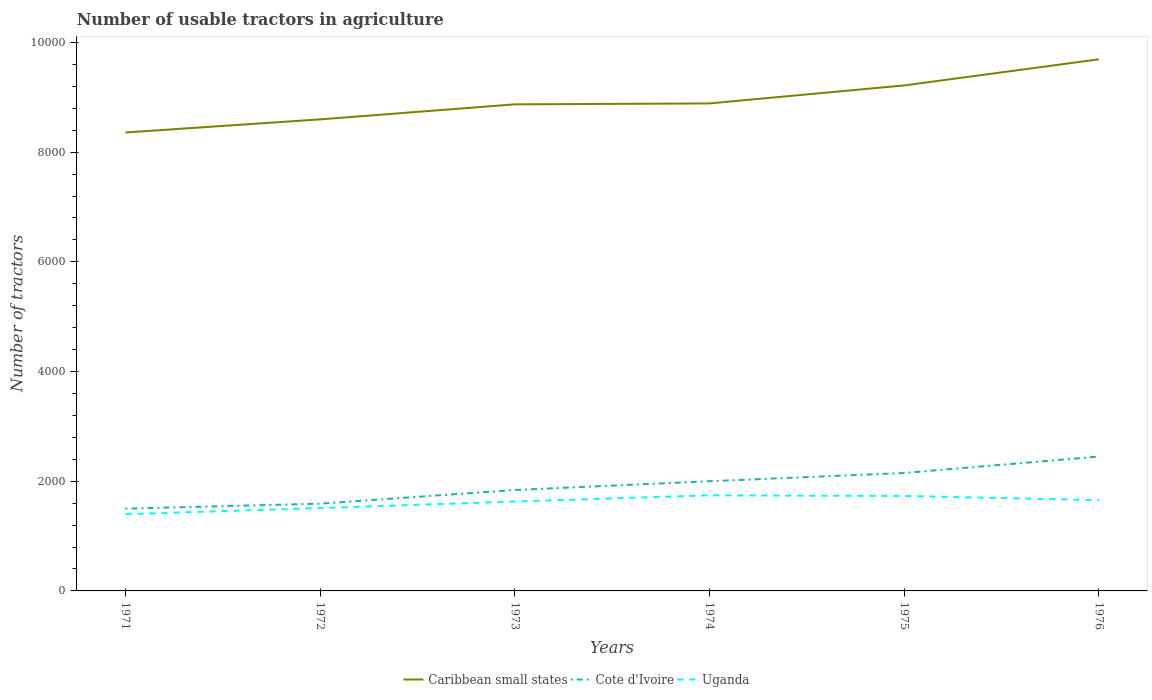How many different coloured lines are there?
Your answer should be very brief. 3. Does the line corresponding to Uganda intersect with the line corresponding to Caribbean small states?
Ensure brevity in your answer.  No. Is the number of lines equal to the number of legend labels?
Your answer should be very brief. Yes. Across all years, what is the maximum number of usable tractors in agriculture in Cote d'Ivoire?
Make the answer very short. 1500. In which year was the number of usable tractors in agriculture in Cote d'Ivoire maximum?
Offer a very short reply. 1971. What is the total number of usable tractors in agriculture in Cote d'Ivoire in the graph?
Your response must be concise. -409. What is the difference between the highest and the second highest number of usable tractors in agriculture in Uganda?
Make the answer very short. 343. What is the difference between the highest and the lowest number of usable tractors in agriculture in Cote d'Ivoire?
Provide a succinct answer. 3. Is the number of usable tractors in agriculture in Uganda strictly greater than the number of usable tractors in agriculture in Caribbean small states over the years?
Provide a short and direct response. Yes. How many lines are there?
Your response must be concise. 3. How many years are there in the graph?
Provide a succinct answer. 6. Does the graph contain grids?
Provide a succinct answer. No. What is the title of the graph?
Provide a succinct answer. Number of usable tractors in agriculture. What is the label or title of the X-axis?
Give a very brief answer. Years. What is the label or title of the Y-axis?
Provide a short and direct response. Number of tractors. What is the Number of tractors of Caribbean small states in 1971?
Your answer should be very brief. 8358. What is the Number of tractors of Cote d'Ivoire in 1971?
Your answer should be compact. 1500. What is the Number of tractors of Uganda in 1971?
Provide a short and direct response. 1400. What is the Number of tractors in Caribbean small states in 1972?
Ensure brevity in your answer.  8597. What is the Number of tractors of Cote d'Ivoire in 1972?
Your answer should be very brief. 1591. What is the Number of tractors of Uganda in 1972?
Ensure brevity in your answer.  1510. What is the Number of tractors of Caribbean small states in 1973?
Your response must be concise. 8871. What is the Number of tractors of Cote d'Ivoire in 1973?
Offer a terse response. 1840. What is the Number of tractors in Uganda in 1973?
Offer a very short reply. 1630. What is the Number of tractors of Caribbean small states in 1974?
Provide a short and direct response. 8888. What is the Number of tractors of Cote d'Ivoire in 1974?
Your answer should be very brief. 2000. What is the Number of tractors of Uganda in 1974?
Keep it short and to the point. 1743. What is the Number of tractors in Caribbean small states in 1975?
Keep it short and to the point. 9216. What is the Number of tractors of Cote d'Ivoire in 1975?
Give a very brief answer. 2150. What is the Number of tractors in Uganda in 1975?
Your answer should be very brief. 1731. What is the Number of tractors of Caribbean small states in 1976?
Offer a terse response. 9692. What is the Number of tractors in Cote d'Ivoire in 1976?
Ensure brevity in your answer.  2450. What is the Number of tractors in Uganda in 1976?
Your response must be concise. 1656. Across all years, what is the maximum Number of tractors in Caribbean small states?
Keep it short and to the point. 9692. Across all years, what is the maximum Number of tractors of Cote d'Ivoire?
Offer a terse response. 2450. Across all years, what is the maximum Number of tractors in Uganda?
Make the answer very short. 1743. Across all years, what is the minimum Number of tractors in Caribbean small states?
Your answer should be very brief. 8358. Across all years, what is the minimum Number of tractors of Cote d'Ivoire?
Keep it short and to the point. 1500. Across all years, what is the minimum Number of tractors of Uganda?
Offer a very short reply. 1400. What is the total Number of tractors in Caribbean small states in the graph?
Offer a very short reply. 5.36e+04. What is the total Number of tractors in Cote d'Ivoire in the graph?
Provide a succinct answer. 1.15e+04. What is the total Number of tractors in Uganda in the graph?
Offer a terse response. 9670. What is the difference between the Number of tractors of Caribbean small states in 1971 and that in 1972?
Keep it short and to the point. -239. What is the difference between the Number of tractors in Cote d'Ivoire in 1971 and that in 1972?
Keep it short and to the point. -91. What is the difference between the Number of tractors of Uganda in 1971 and that in 1972?
Keep it short and to the point. -110. What is the difference between the Number of tractors of Caribbean small states in 1971 and that in 1973?
Provide a succinct answer. -513. What is the difference between the Number of tractors of Cote d'Ivoire in 1971 and that in 1973?
Give a very brief answer. -340. What is the difference between the Number of tractors of Uganda in 1971 and that in 1973?
Your answer should be compact. -230. What is the difference between the Number of tractors of Caribbean small states in 1971 and that in 1974?
Offer a terse response. -530. What is the difference between the Number of tractors of Cote d'Ivoire in 1971 and that in 1974?
Your answer should be very brief. -500. What is the difference between the Number of tractors in Uganda in 1971 and that in 1974?
Keep it short and to the point. -343. What is the difference between the Number of tractors in Caribbean small states in 1971 and that in 1975?
Keep it short and to the point. -858. What is the difference between the Number of tractors in Cote d'Ivoire in 1971 and that in 1975?
Make the answer very short. -650. What is the difference between the Number of tractors in Uganda in 1971 and that in 1975?
Your response must be concise. -331. What is the difference between the Number of tractors in Caribbean small states in 1971 and that in 1976?
Keep it short and to the point. -1334. What is the difference between the Number of tractors in Cote d'Ivoire in 1971 and that in 1976?
Offer a terse response. -950. What is the difference between the Number of tractors of Uganda in 1971 and that in 1976?
Offer a terse response. -256. What is the difference between the Number of tractors in Caribbean small states in 1972 and that in 1973?
Give a very brief answer. -274. What is the difference between the Number of tractors in Cote d'Ivoire in 1972 and that in 1973?
Give a very brief answer. -249. What is the difference between the Number of tractors in Uganda in 1972 and that in 1973?
Your answer should be very brief. -120. What is the difference between the Number of tractors in Caribbean small states in 1972 and that in 1974?
Your answer should be very brief. -291. What is the difference between the Number of tractors in Cote d'Ivoire in 1972 and that in 1974?
Give a very brief answer. -409. What is the difference between the Number of tractors of Uganda in 1972 and that in 1974?
Your answer should be compact. -233. What is the difference between the Number of tractors in Caribbean small states in 1972 and that in 1975?
Make the answer very short. -619. What is the difference between the Number of tractors in Cote d'Ivoire in 1972 and that in 1975?
Ensure brevity in your answer.  -559. What is the difference between the Number of tractors in Uganda in 1972 and that in 1975?
Your answer should be very brief. -221. What is the difference between the Number of tractors of Caribbean small states in 1972 and that in 1976?
Provide a succinct answer. -1095. What is the difference between the Number of tractors in Cote d'Ivoire in 1972 and that in 1976?
Your answer should be very brief. -859. What is the difference between the Number of tractors of Uganda in 1972 and that in 1976?
Offer a terse response. -146. What is the difference between the Number of tractors in Cote d'Ivoire in 1973 and that in 1974?
Ensure brevity in your answer.  -160. What is the difference between the Number of tractors in Uganda in 1973 and that in 1974?
Your answer should be very brief. -113. What is the difference between the Number of tractors in Caribbean small states in 1973 and that in 1975?
Offer a very short reply. -345. What is the difference between the Number of tractors in Cote d'Ivoire in 1973 and that in 1975?
Ensure brevity in your answer.  -310. What is the difference between the Number of tractors in Uganda in 1973 and that in 1975?
Your response must be concise. -101. What is the difference between the Number of tractors in Caribbean small states in 1973 and that in 1976?
Make the answer very short. -821. What is the difference between the Number of tractors of Cote d'Ivoire in 1973 and that in 1976?
Ensure brevity in your answer.  -610. What is the difference between the Number of tractors of Caribbean small states in 1974 and that in 1975?
Offer a terse response. -328. What is the difference between the Number of tractors in Cote d'Ivoire in 1974 and that in 1975?
Provide a short and direct response. -150. What is the difference between the Number of tractors of Caribbean small states in 1974 and that in 1976?
Give a very brief answer. -804. What is the difference between the Number of tractors of Cote d'Ivoire in 1974 and that in 1976?
Ensure brevity in your answer.  -450. What is the difference between the Number of tractors of Uganda in 1974 and that in 1976?
Your response must be concise. 87. What is the difference between the Number of tractors in Caribbean small states in 1975 and that in 1976?
Your answer should be very brief. -476. What is the difference between the Number of tractors in Cote d'Ivoire in 1975 and that in 1976?
Offer a very short reply. -300. What is the difference between the Number of tractors of Uganda in 1975 and that in 1976?
Your answer should be very brief. 75. What is the difference between the Number of tractors in Caribbean small states in 1971 and the Number of tractors in Cote d'Ivoire in 1972?
Provide a succinct answer. 6767. What is the difference between the Number of tractors of Caribbean small states in 1971 and the Number of tractors of Uganda in 1972?
Keep it short and to the point. 6848. What is the difference between the Number of tractors in Cote d'Ivoire in 1971 and the Number of tractors in Uganda in 1972?
Ensure brevity in your answer.  -10. What is the difference between the Number of tractors of Caribbean small states in 1971 and the Number of tractors of Cote d'Ivoire in 1973?
Your response must be concise. 6518. What is the difference between the Number of tractors of Caribbean small states in 1971 and the Number of tractors of Uganda in 1973?
Offer a very short reply. 6728. What is the difference between the Number of tractors of Cote d'Ivoire in 1971 and the Number of tractors of Uganda in 1973?
Give a very brief answer. -130. What is the difference between the Number of tractors of Caribbean small states in 1971 and the Number of tractors of Cote d'Ivoire in 1974?
Offer a very short reply. 6358. What is the difference between the Number of tractors in Caribbean small states in 1971 and the Number of tractors in Uganda in 1974?
Keep it short and to the point. 6615. What is the difference between the Number of tractors of Cote d'Ivoire in 1971 and the Number of tractors of Uganda in 1974?
Give a very brief answer. -243. What is the difference between the Number of tractors of Caribbean small states in 1971 and the Number of tractors of Cote d'Ivoire in 1975?
Your answer should be compact. 6208. What is the difference between the Number of tractors of Caribbean small states in 1971 and the Number of tractors of Uganda in 1975?
Provide a short and direct response. 6627. What is the difference between the Number of tractors in Cote d'Ivoire in 1971 and the Number of tractors in Uganda in 1975?
Provide a succinct answer. -231. What is the difference between the Number of tractors in Caribbean small states in 1971 and the Number of tractors in Cote d'Ivoire in 1976?
Your answer should be compact. 5908. What is the difference between the Number of tractors in Caribbean small states in 1971 and the Number of tractors in Uganda in 1976?
Provide a succinct answer. 6702. What is the difference between the Number of tractors in Cote d'Ivoire in 1971 and the Number of tractors in Uganda in 1976?
Keep it short and to the point. -156. What is the difference between the Number of tractors in Caribbean small states in 1972 and the Number of tractors in Cote d'Ivoire in 1973?
Ensure brevity in your answer.  6757. What is the difference between the Number of tractors of Caribbean small states in 1972 and the Number of tractors of Uganda in 1973?
Provide a short and direct response. 6967. What is the difference between the Number of tractors of Cote d'Ivoire in 1972 and the Number of tractors of Uganda in 1973?
Your answer should be compact. -39. What is the difference between the Number of tractors in Caribbean small states in 1972 and the Number of tractors in Cote d'Ivoire in 1974?
Make the answer very short. 6597. What is the difference between the Number of tractors of Caribbean small states in 1972 and the Number of tractors of Uganda in 1974?
Keep it short and to the point. 6854. What is the difference between the Number of tractors of Cote d'Ivoire in 1972 and the Number of tractors of Uganda in 1974?
Your answer should be compact. -152. What is the difference between the Number of tractors of Caribbean small states in 1972 and the Number of tractors of Cote d'Ivoire in 1975?
Provide a short and direct response. 6447. What is the difference between the Number of tractors of Caribbean small states in 1972 and the Number of tractors of Uganda in 1975?
Offer a very short reply. 6866. What is the difference between the Number of tractors in Cote d'Ivoire in 1972 and the Number of tractors in Uganda in 1975?
Make the answer very short. -140. What is the difference between the Number of tractors in Caribbean small states in 1972 and the Number of tractors in Cote d'Ivoire in 1976?
Your answer should be compact. 6147. What is the difference between the Number of tractors in Caribbean small states in 1972 and the Number of tractors in Uganda in 1976?
Your response must be concise. 6941. What is the difference between the Number of tractors of Cote d'Ivoire in 1972 and the Number of tractors of Uganda in 1976?
Make the answer very short. -65. What is the difference between the Number of tractors in Caribbean small states in 1973 and the Number of tractors in Cote d'Ivoire in 1974?
Your answer should be very brief. 6871. What is the difference between the Number of tractors in Caribbean small states in 1973 and the Number of tractors in Uganda in 1974?
Provide a succinct answer. 7128. What is the difference between the Number of tractors of Cote d'Ivoire in 1973 and the Number of tractors of Uganda in 1974?
Keep it short and to the point. 97. What is the difference between the Number of tractors of Caribbean small states in 1973 and the Number of tractors of Cote d'Ivoire in 1975?
Make the answer very short. 6721. What is the difference between the Number of tractors of Caribbean small states in 1973 and the Number of tractors of Uganda in 1975?
Offer a very short reply. 7140. What is the difference between the Number of tractors of Cote d'Ivoire in 1973 and the Number of tractors of Uganda in 1975?
Make the answer very short. 109. What is the difference between the Number of tractors in Caribbean small states in 1973 and the Number of tractors in Cote d'Ivoire in 1976?
Give a very brief answer. 6421. What is the difference between the Number of tractors of Caribbean small states in 1973 and the Number of tractors of Uganda in 1976?
Provide a succinct answer. 7215. What is the difference between the Number of tractors in Cote d'Ivoire in 1973 and the Number of tractors in Uganda in 1976?
Offer a terse response. 184. What is the difference between the Number of tractors of Caribbean small states in 1974 and the Number of tractors of Cote d'Ivoire in 1975?
Ensure brevity in your answer.  6738. What is the difference between the Number of tractors in Caribbean small states in 1974 and the Number of tractors in Uganda in 1975?
Your answer should be compact. 7157. What is the difference between the Number of tractors of Cote d'Ivoire in 1974 and the Number of tractors of Uganda in 1975?
Your response must be concise. 269. What is the difference between the Number of tractors in Caribbean small states in 1974 and the Number of tractors in Cote d'Ivoire in 1976?
Provide a short and direct response. 6438. What is the difference between the Number of tractors in Caribbean small states in 1974 and the Number of tractors in Uganda in 1976?
Offer a very short reply. 7232. What is the difference between the Number of tractors in Cote d'Ivoire in 1974 and the Number of tractors in Uganda in 1976?
Give a very brief answer. 344. What is the difference between the Number of tractors of Caribbean small states in 1975 and the Number of tractors of Cote d'Ivoire in 1976?
Give a very brief answer. 6766. What is the difference between the Number of tractors of Caribbean small states in 1975 and the Number of tractors of Uganda in 1976?
Offer a terse response. 7560. What is the difference between the Number of tractors in Cote d'Ivoire in 1975 and the Number of tractors in Uganda in 1976?
Make the answer very short. 494. What is the average Number of tractors of Caribbean small states per year?
Offer a terse response. 8937. What is the average Number of tractors of Cote d'Ivoire per year?
Offer a very short reply. 1921.83. What is the average Number of tractors in Uganda per year?
Provide a short and direct response. 1611.67. In the year 1971, what is the difference between the Number of tractors of Caribbean small states and Number of tractors of Cote d'Ivoire?
Provide a short and direct response. 6858. In the year 1971, what is the difference between the Number of tractors in Caribbean small states and Number of tractors in Uganda?
Provide a short and direct response. 6958. In the year 1972, what is the difference between the Number of tractors in Caribbean small states and Number of tractors in Cote d'Ivoire?
Offer a terse response. 7006. In the year 1972, what is the difference between the Number of tractors in Caribbean small states and Number of tractors in Uganda?
Offer a very short reply. 7087. In the year 1972, what is the difference between the Number of tractors in Cote d'Ivoire and Number of tractors in Uganda?
Offer a terse response. 81. In the year 1973, what is the difference between the Number of tractors in Caribbean small states and Number of tractors in Cote d'Ivoire?
Make the answer very short. 7031. In the year 1973, what is the difference between the Number of tractors of Caribbean small states and Number of tractors of Uganda?
Keep it short and to the point. 7241. In the year 1973, what is the difference between the Number of tractors of Cote d'Ivoire and Number of tractors of Uganda?
Provide a short and direct response. 210. In the year 1974, what is the difference between the Number of tractors in Caribbean small states and Number of tractors in Cote d'Ivoire?
Give a very brief answer. 6888. In the year 1974, what is the difference between the Number of tractors in Caribbean small states and Number of tractors in Uganda?
Your answer should be very brief. 7145. In the year 1974, what is the difference between the Number of tractors in Cote d'Ivoire and Number of tractors in Uganda?
Make the answer very short. 257. In the year 1975, what is the difference between the Number of tractors of Caribbean small states and Number of tractors of Cote d'Ivoire?
Your answer should be very brief. 7066. In the year 1975, what is the difference between the Number of tractors in Caribbean small states and Number of tractors in Uganda?
Keep it short and to the point. 7485. In the year 1975, what is the difference between the Number of tractors in Cote d'Ivoire and Number of tractors in Uganda?
Make the answer very short. 419. In the year 1976, what is the difference between the Number of tractors of Caribbean small states and Number of tractors of Cote d'Ivoire?
Provide a short and direct response. 7242. In the year 1976, what is the difference between the Number of tractors in Caribbean small states and Number of tractors in Uganda?
Provide a short and direct response. 8036. In the year 1976, what is the difference between the Number of tractors of Cote d'Ivoire and Number of tractors of Uganda?
Your answer should be very brief. 794. What is the ratio of the Number of tractors of Caribbean small states in 1971 to that in 1972?
Give a very brief answer. 0.97. What is the ratio of the Number of tractors in Cote d'Ivoire in 1971 to that in 1972?
Provide a short and direct response. 0.94. What is the ratio of the Number of tractors of Uganda in 1971 to that in 1972?
Provide a short and direct response. 0.93. What is the ratio of the Number of tractors of Caribbean small states in 1971 to that in 1973?
Provide a short and direct response. 0.94. What is the ratio of the Number of tractors in Cote d'Ivoire in 1971 to that in 1973?
Give a very brief answer. 0.82. What is the ratio of the Number of tractors of Uganda in 1971 to that in 1973?
Provide a succinct answer. 0.86. What is the ratio of the Number of tractors of Caribbean small states in 1971 to that in 1974?
Provide a succinct answer. 0.94. What is the ratio of the Number of tractors of Cote d'Ivoire in 1971 to that in 1974?
Make the answer very short. 0.75. What is the ratio of the Number of tractors of Uganda in 1971 to that in 1974?
Provide a succinct answer. 0.8. What is the ratio of the Number of tractors in Caribbean small states in 1971 to that in 1975?
Your answer should be compact. 0.91. What is the ratio of the Number of tractors in Cote d'Ivoire in 1971 to that in 1975?
Make the answer very short. 0.7. What is the ratio of the Number of tractors in Uganda in 1971 to that in 1975?
Your answer should be compact. 0.81. What is the ratio of the Number of tractors of Caribbean small states in 1971 to that in 1976?
Your response must be concise. 0.86. What is the ratio of the Number of tractors of Cote d'Ivoire in 1971 to that in 1976?
Make the answer very short. 0.61. What is the ratio of the Number of tractors of Uganda in 1971 to that in 1976?
Make the answer very short. 0.85. What is the ratio of the Number of tractors in Caribbean small states in 1972 to that in 1973?
Make the answer very short. 0.97. What is the ratio of the Number of tractors in Cote d'Ivoire in 1972 to that in 1973?
Keep it short and to the point. 0.86. What is the ratio of the Number of tractors in Uganda in 1972 to that in 1973?
Keep it short and to the point. 0.93. What is the ratio of the Number of tractors in Caribbean small states in 1972 to that in 1974?
Provide a succinct answer. 0.97. What is the ratio of the Number of tractors in Cote d'Ivoire in 1972 to that in 1974?
Your answer should be compact. 0.8. What is the ratio of the Number of tractors of Uganda in 1972 to that in 1974?
Offer a very short reply. 0.87. What is the ratio of the Number of tractors in Caribbean small states in 1972 to that in 1975?
Your answer should be compact. 0.93. What is the ratio of the Number of tractors of Cote d'Ivoire in 1972 to that in 1975?
Keep it short and to the point. 0.74. What is the ratio of the Number of tractors in Uganda in 1972 to that in 1975?
Your response must be concise. 0.87. What is the ratio of the Number of tractors of Caribbean small states in 1972 to that in 1976?
Make the answer very short. 0.89. What is the ratio of the Number of tractors in Cote d'Ivoire in 1972 to that in 1976?
Your answer should be compact. 0.65. What is the ratio of the Number of tractors in Uganda in 1972 to that in 1976?
Give a very brief answer. 0.91. What is the ratio of the Number of tractors in Caribbean small states in 1973 to that in 1974?
Offer a terse response. 1. What is the ratio of the Number of tractors in Uganda in 1973 to that in 1974?
Make the answer very short. 0.94. What is the ratio of the Number of tractors in Caribbean small states in 1973 to that in 1975?
Offer a terse response. 0.96. What is the ratio of the Number of tractors of Cote d'Ivoire in 1973 to that in 1975?
Ensure brevity in your answer.  0.86. What is the ratio of the Number of tractors in Uganda in 1973 to that in 1975?
Your answer should be compact. 0.94. What is the ratio of the Number of tractors of Caribbean small states in 1973 to that in 1976?
Provide a succinct answer. 0.92. What is the ratio of the Number of tractors in Cote d'Ivoire in 1973 to that in 1976?
Offer a very short reply. 0.75. What is the ratio of the Number of tractors of Uganda in 1973 to that in 1976?
Give a very brief answer. 0.98. What is the ratio of the Number of tractors in Caribbean small states in 1974 to that in 1975?
Ensure brevity in your answer.  0.96. What is the ratio of the Number of tractors of Cote d'Ivoire in 1974 to that in 1975?
Your answer should be compact. 0.93. What is the ratio of the Number of tractors of Uganda in 1974 to that in 1975?
Offer a very short reply. 1.01. What is the ratio of the Number of tractors in Caribbean small states in 1974 to that in 1976?
Keep it short and to the point. 0.92. What is the ratio of the Number of tractors in Cote d'Ivoire in 1974 to that in 1976?
Your response must be concise. 0.82. What is the ratio of the Number of tractors in Uganda in 1974 to that in 1976?
Provide a short and direct response. 1.05. What is the ratio of the Number of tractors in Caribbean small states in 1975 to that in 1976?
Give a very brief answer. 0.95. What is the ratio of the Number of tractors in Cote d'Ivoire in 1975 to that in 1976?
Provide a succinct answer. 0.88. What is the ratio of the Number of tractors of Uganda in 1975 to that in 1976?
Ensure brevity in your answer.  1.05. What is the difference between the highest and the second highest Number of tractors of Caribbean small states?
Give a very brief answer. 476. What is the difference between the highest and the second highest Number of tractors in Cote d'Ivoire?
Give a very brief answer. 300. What is the difference between the highest and the lowest Number of tractors of Caribbean small states?
Provide a succinct answer. 1334. What is the difference between the highest and the lowest Number of tractors of Cote d'Ivoire?
Keep it short and to the point. 950. What is the difference between the highest and the lowest Number of tractors in Uganda?
Provide a succinct answer. 343. 